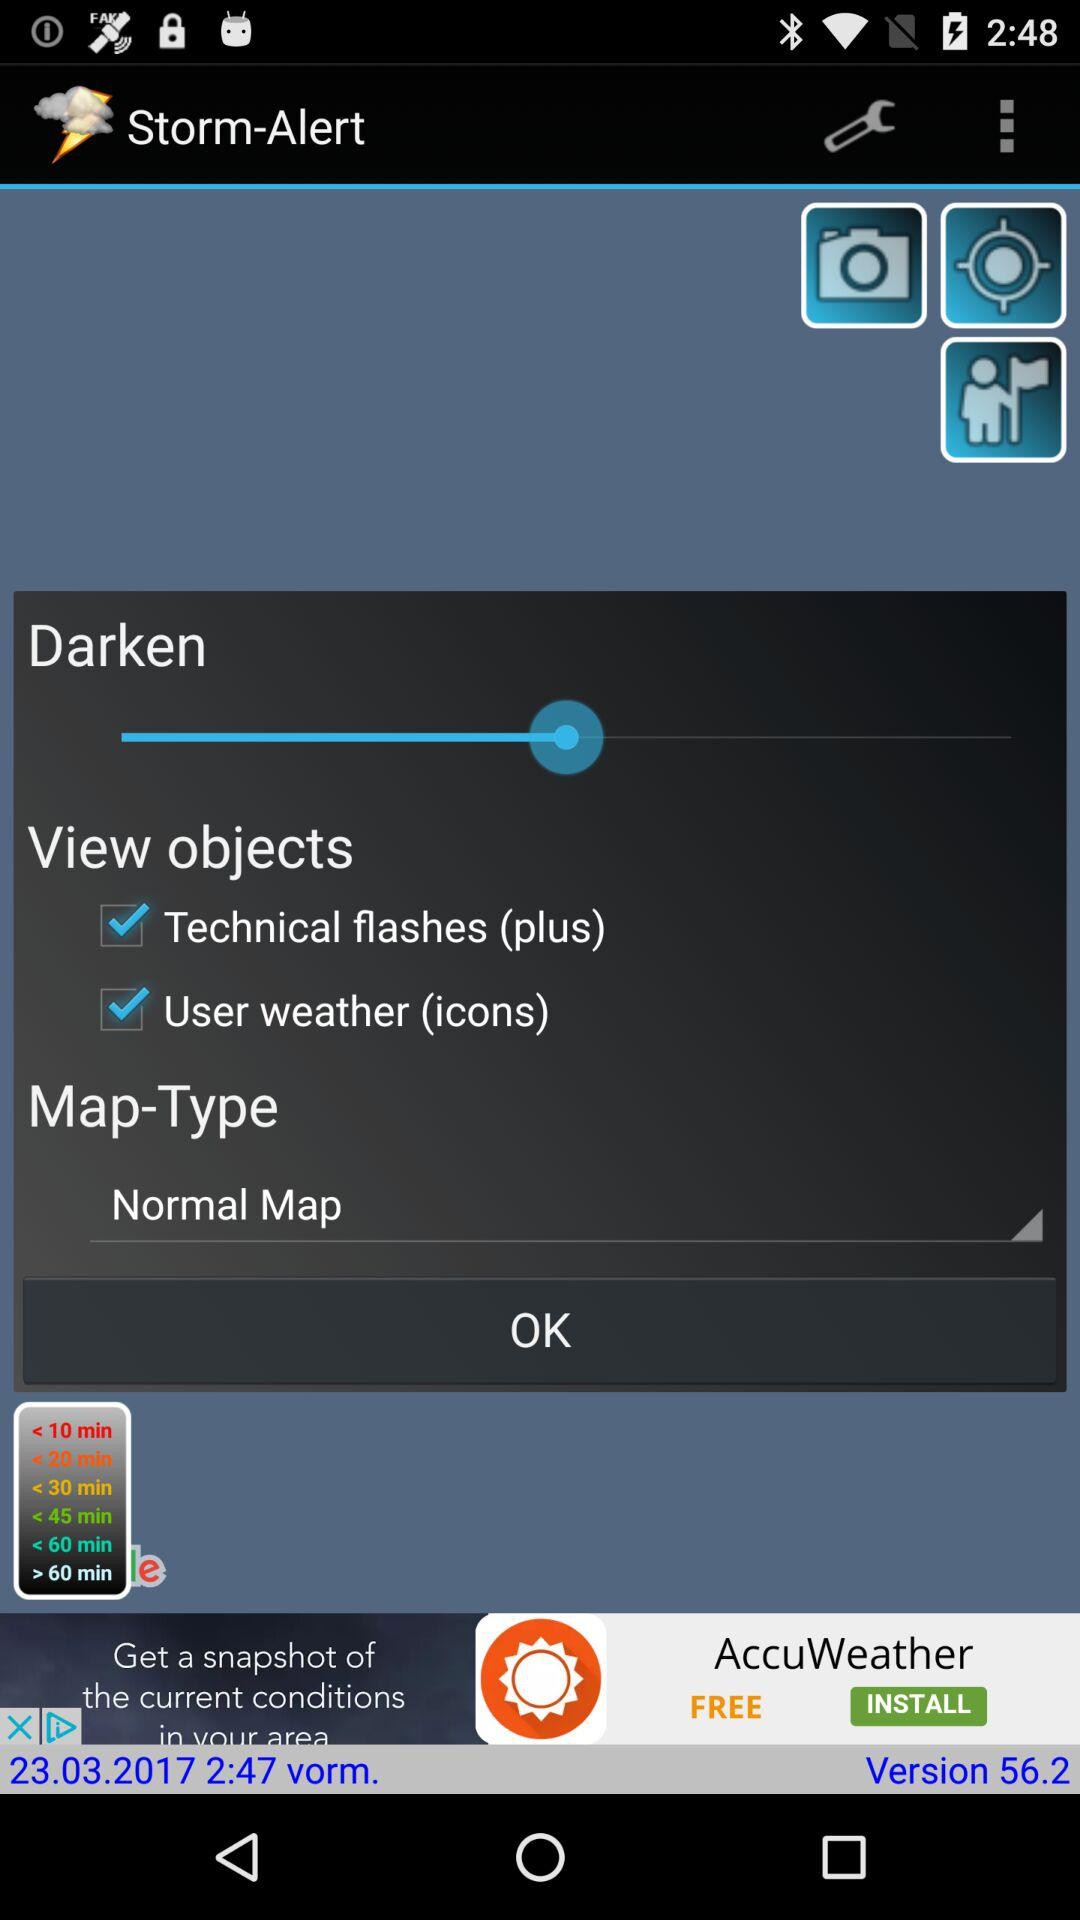What is the name of the application? The name of the application is "Storm-Alert". 